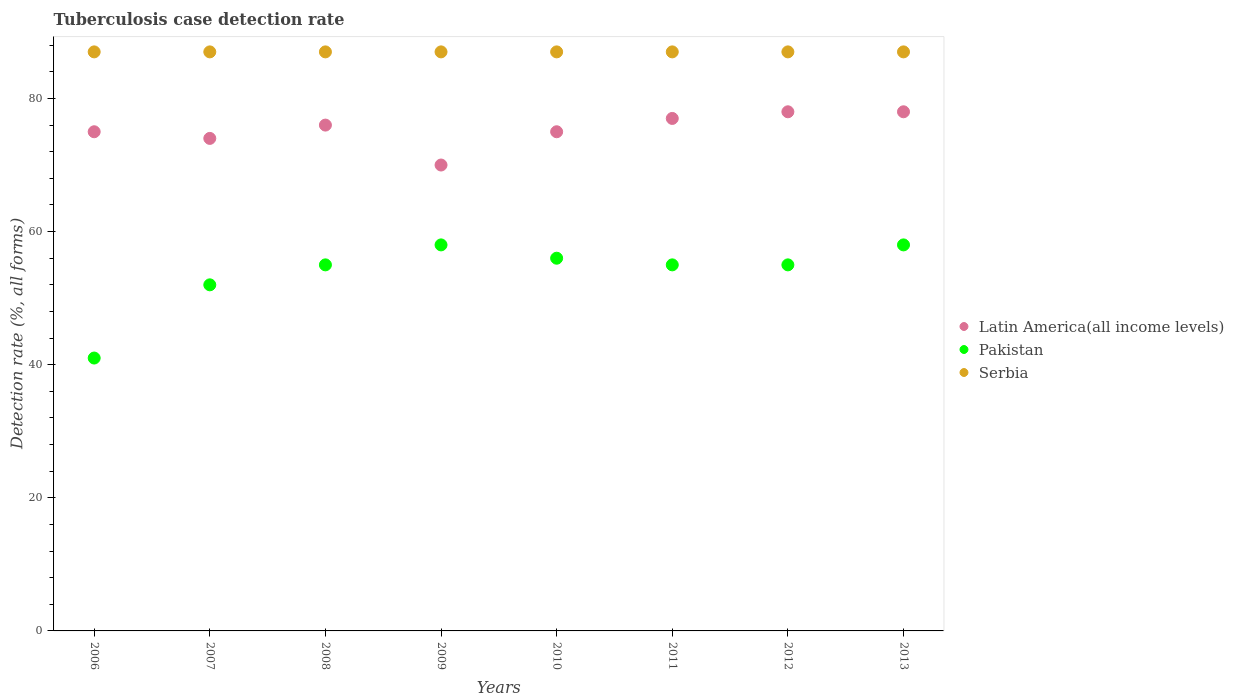Is the number of dotlines equal to the number of legend labels?
Provide a succinct answer. Yes. What is the tuberculosis case detection rate in in Latin America(all income levels) in 2011?
Provide a short and direct response. 77. Across all years, what is the maximum tuberculosis case detection rate in in Serbia?
Offer a terse response. 87. Across all years, what is the minimum tuberculosis case detection rate in in Latin America(all income levels)?
Your answer should be compact. 70. In which year was the tuberculosis case detection rate in in Latin America(all income levels) maximum?
Offer a terse response. 2012. In which year was the tuberculosis case detection rate in in Pakistan minimum?
Provide a succinct answer. 2006. What is the total tuberculosis case detection rate in in Latin America(all income levels) in the graph?
Your response must be concise. 603. What is the difference between the tuberculosis case detection rate in in Pakistan in 2009 and that in 2011?
Keep it short and to the point. 3. What is the difference between the tuberculosis case detection rate in in Latin America(all income levels) in 2011 and the tuberculosis case detection rate in in Serbia in 2007?
Your response must be concise. -10. What is the average tuberculosis case detection rate in in Serbia per year?
Make the answer very short. 87. In how many years, is the tuberculosis case detection rate in in Serbia greater than 80 %?
Your response must be concise. 8. What is the ratio of the tuberculosis case detection rate in in Latin America(all income levels) in 2008 to that in 2010?
Your answer should be compact. 1.01. Is the tuberculosis case detection rate in in Latin America(all income levels) in 2007 less than that in 2012?
Provide a succinct answer. Yes. Is the difference between the tuberculosis case detection rate in in Pakistan in 2011 and 2013 greater than the difference between the tuberculosis case detection rate in in Latin America(all income levels) in 2011 and 2013?
Ensure brevity in your answer.  No. What is the difference between the highest and the lowest tuberculosis case detection rate in in Serbia?
Offer a very short reply. 0. In how many years, is the tuberculosis case detection rate in in Serbia greater than the average tuberculosis case detection rate in in Serbia taken over all years?
Your answer should be very brief. 0. Is the sum of the tuberculosis case detection rate in in Serbia in 2006 and 2012 greater than the maximum tuberculosis case detection rate in in Pakistan across all years?
Your answer should be very brief. Yes. Is it the case that in every year, the sum of the tuberculosis case detection rate in in Pakistan and tuberculosis case detection rate in in Serbia  is greater than the tuberculosis case detection rate in in Latin America(all income levels)?
Your answer should be very brief. Yes. Is the tuberculosis case detection rate in in Pakistan strictly less than the tuberculosis case detection rate in in Latin America(all income levels) over the years?
Your response must be concise. Yes. How many years are there in the graph?
Provide a succinct answer. 8. What is the difference between two consecutive major ticks on the Y-axis?
Provide a succinct answer. 20. Does the graph contain grids?
Make the answer very short. No. How many legend labels are there?
Provide a succinct answer. 3. How are the legend labels stacked?
Your answer should be compact. Vertical. What is the title of the graph?
Give a very brief answer. Tuberculosis case detection rate. What is the label or title of the Y-axis?
Offer a terse response. Detection rate (%, all forms). What is the Detection rate (%, all forms) in Latin America(all income levels) in 2006?
Your answer should be compact. 75. What is the Detection rate (%, all forms) in Pakistan in 2007?
Offer a very short reply. 52. What is the Detection rate (%, all forms) of Latin America(all income levels) in 2008?
Give a very brief answer. 76. What is the Detection rate (%, all forms) in Pakistan in 2008?
Make the answer very short. 55. What is the Detection rate (%, all forms) of Latin America(all income levels) in 2009?
Your answer should be compact. 70. What is the Detection rate (%, all forms) of Pakistan in 2009?
Offer a very short reply. 58. What is the Detection rate (%, all forms) of Pakistan in 2010?
Give a very brief answer. 56. What is the Detection rate (%, all forms) in Serbia in 2011?
Make the answer very short. 87. What is the Detection rate (%, all forms) of Serbia in 2012?
Provide a short and direct response. 87. What is the Detection rate (%, all forms) of Latin America(all income levels) in 2013?
Offer a very short reply. 78. Across all years, what is the maximum Detection rate (%, all forms) in Latin America(all income levels)?
Offer a terse response. 78. Across all years, what is the maximum Detection rate (%, all forms) of Pakistan?
Your response must be concise. 58. Across all years, what is the maximum Detection rate (%, all forms) in Serbia?
Your answer should be compact. 87. Across all years, what is the minimum Detection rate (%, all forms) of Serbia?
Offer a terse response. 87. What is the total Detection rate (%, all forms) of Latin America(all income levels) in the graph?
Ensure brevity in your answer.  603. What is the total Detection rate (%, all forms) of Pakistan in the graph?
Give a very brief answer. 430. What is the total Detection rate (%, all forms) of Serbia in the graph?
Provide a short and direct response. 696. What is the difference between the Detection rate (%, all forms) in Latin America(all income levels) in 2006 and that in 2007?
Your response must be concise. 1. What is the difference between the Detection rate (%, all forms) in Serbia in 2006 and that in 2007?
Offer a very short reply. 0. What is the difference between the Detection rate (%, all forms) in Serbia in 2006 and that in 2008?
Offer a very short reply. 0. What is the difference between the Detection rate (%, all forms) in Serbia in 2006 and that in 2009?
Keep it short and to the point. 0. What is the difference between the Detection rate (%, all forms) in Serbia in 2006 and that in 2010?
Your response must be concise. 0. What is the difference between the Detection rate (%, all forms) in Pakistan in 2006 and that in 2011?
Provide a succinct answer. -14. What is the difference between the Detection rate (%, all forms) in Serbia in 2006 and that in 2011?
Your answer should be very brief. 0. What is the difference between the Detection rate (%, all forms) in Latin America(all income levels) in 2006 and that in 2012?
Offer a very short reply. -3. What is the difference between the Detection rate (%, all forms) of Pakistan in 2006 and that in 2012?
Provide a succinct answer. -14. What is the difference between the Detection rate (%, all forms) of Latin America(all income levels) in 2006 and that in 2013?
Make the answer very short. -3. What is the difference between the Detection rate (%, all forms) of Pakistan in 2006 and that in 2013?
Make the answer very short. -17. What is the difference between the Detection rate (%, all forms) of Serbia in 2006 and that in 2013?
Ensure brevity in your answer.  0. What is the difference between the Detection rate (%, all forms) in Latin America(all income levels) in 2007 and that in 2008?
Give a very brief answer. -2. What is the difference between the Detection rate (%, all forms) of Pakistan in 2007 and that in 2008?
Give a very brief answer. -3. What is the difference between the Detection rate (%, all forms) in Serbia in 2007 and that in 2008?
Provide a short and direct response. 0. What is the difference between the Detection rate (%, all forms) of Latin America(all income levels) in 2007 and that in 2009?
Offer a terse response. 4. What is the difference between the Detection rate (%, all forms) in Pakistan in 2007 and that in 2010?
Your answer should be very brief. -4. What is the difference between the Detection rate (%, all forms) in Latin America(all income levels) in 2007 and that in 2011?
Provide a succinct answer. -3. What is the difference between the Detection rate (%, all forms) in Pakistan in 2007 and that in 2011?
Ensure brevity in your answer.  -3. What is the difference between the Detection rate (%, all forms) in Latin America(all income levels) in 2007 and that in 2013?
Provide a short and direct response. -4. What is the difference between the Detection rate (%, all forms) in Pakistan in 2007 and that in 2013?
Ensure brevity in your answer.  -6. What is the difference between the Detection rate (%, all forms) of Serbia in 2007 and that in 2013?
Provide a short and direct response. 0. What is the difference between the Detection rate (%, all forms) of Pakistan in 2008 and that in 2009?
Keep it short and to the point. -3. What is the difference between the Detection rate (%, all forms) of Serbia in 2008 and that in 2009?
Your response must be concise. 0. What is the difference between the Detection rate (%, all forms) in Latin America(all income levels) in 2008 and that in 2010?
Make the answer very short. 1. What is the difference between the Detection rate (%, all forms) of Serbia in 2008 and that in 2010?
Your answer should be compact. 0. What is the difference between the Detection rate (%, all forms) of Latin America(all income levels) in 2008 and that in 2012?
Ensure brevity in your answer.  -2. What is the difference between the Detection rate (%, all forms) in Pakistan in 2008 and that in 2012?
Your response must be concise. 0. What is the difference between the Detection rate (%, all forms) in Latin America(all income levels) in 2008 and that in 2013?
Give a very brief answer. -2. What is the difference between the Detection rate (%, all forms) in Serbia in 2008 and that in 2013?
Your response must be concise. 0. What is the difference between the Detection rate (%, all forms) of Latin America(all income levels) in 2009 and that in 2010?
Provide a short and direct response. -5. What is the difference between the Detection rate (%, all forms) in Pakistan in 2009 and that in 2010?
Give a very brief answer. 2. What is the difference between the Detection rate (%, all forms) in Serbia in 2009 and that in 2010?
Your answer should be compact. 0. What is the difference between the Detection rate (%, all forms) in Latin America(all income levels) in 2009 and that in 2011?
Ensure brevity in your answer.  -7. What is the difference between the Detection rate (%, all forms) of Pakistan in 2009 and that in 2011?
Your answer should be very brief. 3. What is the difference between the Detection rate (%, all forms) in Serbia in 2009 and that in 2011?
Offer a very short reply. 0. What is the difference between the Detection rate (%, all forms) of Latin America(all income levels) in 2009 and that in 2012?
Your answer should be compact. -8. What is the difference between the Detection rate (%, all forms) of Pakistan in 2009 and that in 2012?
Keep it short and to the point. 3. What is the difference between the Detection rate (%, all forms) of Pakistan in 2009 and that in 2013?
Give a very brief answer. 0. What is the difference between the Detection rate (%, all forms) of Serbia in 2010 and that in 2012?
Keep it short and to the point. 0. What is the difference between the Detection rate (%, all forms) of Pakistan in 2010 and that in 2013?
Keep it short and to the point. -2. What is the difference between the Detection rate (%, all forms) in Serbia in 2010 and that in 2013?
Offer a very short reply. 0. What is the difference between the Detection rate (%, all forms) of Serbia in 2011 and that in 2012?
Make the answer very short. 0. What is the difference between the Detection rate (%, all forms) of Pakistan in 2011 and that in 2013?
Make the answer very short. -3. What is the difference between the Detection rate (%, all forms) of Serbia in 2011 and that in 2013?
Offer a terse response. 0. What is the difference between the Detection rate (%, all forms) of Serbia in 2012 and that in 2013?
Provide a succinct answer. 0. What is the difference between the Detection rate (%, all forms) in Latin America(all income levels) in 2006 and the Detection rate (%, all forms) in Serbia in 2007?
Provide a succinct answer. -12. What is the difference between the Detection rate (%, all forms) of Pakistan in 2006 and the Detection rate (%, all forms) of Serbia in 2007?
Provide a succinct answer. -46. What is the difference between the Detection rate (%, all forms) of Latin America(all income levels) in 2006 and the Detection rate (%, all forms) of Serbia in 2008?
Keep it short and to the point. -12. What is the difference between the Detection rate (%, all forms) in Pakistan in 2006 and the Detection rate (%, all forms) in Serbia in 2008?
Give a very brief answer. -46. What is the difference between the Detection rate (%, all forms) in Latin America(all income levels) in 2006 and the Detection rate (%, all forms) in Pakistan in 2009?
Keep it short and to the point. 17. What is the difference between the Detection rate (%, all forms) in Pakistan in 2006 and the Detection rate (%, all forms) in Serbia in 2009?
Offer a very short reply. -46. What is the difference between the Detection rate (%, all forms) of Latin America(all income levels) in 2006 and the Detection rate (%, all forms) of Pakistan in 2010?
Give a very brief answer. 19. What is the difference between the Detection rate (%, all forms) in Latin America(all income levels) in 2006 and the Detection rate (%, all forms) in Serbia in 2010?
Your answer should be very brief. -12. What is the difference between the Detection rate (%, all forms) of Pakistan in 2006 and the Detection rate (%, all forms) of Serbia in 2010?
Offer a very short reply. -46. What is the difference between the Detection rate (%, all forms) of Latin America(all income levels) in 2006 and the Detection rate (%, all forms) of Serbia in 2011?
Your response must be concise. -12. What is the difference between the Detection rate (%, all forms) of Pakistan in 2006 and the Detection rate (%, all forms) of Serbia in 2011?
Your answer should be compact. -46. What is the difference between the Detection rate (%, all forms) in Latin America(all income levels) in 2006 and the Detection rate (%, all forms) in Pakistan in 2012?
Provide a short and direct response. 20. What is the difference between the Detection rate (%, all forms) in Pakistan in 2006 and the Detection rate (%, all forms) in Serbia in 2012?
Offer a terse response. -46. What is the difference between the Detection rate (%, all forms) of Latin America(all income levels) in 2006 and the Detection rate (%, all forms) of Serbia in 2013?
Your answer should be compact. -12. What is the difference between the Detection rate (%, all forms) in Pakistan in 2006 and the Detection rate (%, all forms) in Serbia in 2013?
Provide a short and direct response. -46. What is the difference between the Detection rate (%, all forms) in Latin America(all income levels) in 2007 and the Detection rate (%, all forms) in Pakistan in 2008?
Offer a very short reply. 19. What is the difference between the Detection rate (%, all forms) of Pakistan in 2007 and the Detection rate (%, all forms) of Serbia in 2008?
Provide a short and direct response. -35. What is the difference between the Detection rate (%, all forms) of Latin America(all income levels) in 2007 and the Detection rate (%, all forms) of Pakistan in 2009?
Give a very brief answer. 16. What is the difference between the Detection rate (%, all forms) of Latin America(all income levels) in 2007 and the Detection rate (%, all forms) of Serbia in 2009?
Ensure brevity in your answer.  -13. What is the difference between the Detection rate (%, all forms) of Pakistan in 2007 and the Detection rate (%, all forms) of Serbia in 2009?
Your answer should be very brief. -35. What is the difference between the Detection rate (%, all forms) of Latin America(all income levels) in 2007 and the Detection rate (%, all forms) of Serbia in 2010?
Offer a very short reply. -13. What is the difference between the Detection rate (%, all forms) of Pakistan in 2007 and the Detection rate (%, all forms) of Serbia in 2010?
Provide a short and direct response. -35. What is the difference between the Detection rate (%, all forms) in Pakistan in 2007 and the Detection rate (%, all forms) in Serbia in 2011?
Offer a terse response. -35. What is the difference between the Detection rate (%, all forms) in Latin America(all income levels) in 2007 and the Detection rate (%, all forms) in Pakistan in 2012?
Make the answer very short. 19. What is the difference between the Detection rate (%, all forms) of Pakistan in 2007 and the Detection rate (%, all forms) of Serbia in 2012?
Offer a very short reply. -35. What is the difference between the Detection rate (%, all forms) in Latin America(all income levels) in 2007 and the Detection rate (%, all forms) in Serbia in 2013?
Give a very brief answer. -13. What is the difference between the Detection rate (%, all forms) of Pakistan in 2007 and the Detection rate (%, all forms) of Serbia in 2013?
Give a very brief answer. -35. What is the difference between the Detection rate (%, all forms) of Pakistan in 2008 and the Detection rate (%, all forms) of Serbia in 2009?
Your response must be concise. -32. What is the difference between the Detection rate (%, all forms) of Pakistan in 2008 and the Detection rate (%, all forms) of Serbia in 2010?
Make the answer very short. -32. What is the difference between the Detection rate (%, all forms) of Latin America(all income levels) in 2008 and the Detection rate (%, all forms) of Pakistan in 2011?
Your response must be concise. 21. What is the difference between the Detection rate (%, all forms) in Latin America(all income levels) in 2008 and the Detection rate (%, all forms) in Serbia in 2011?
Keep it short and to the point. -11. What is the difference between the Detection rate (%, all forms) of Pakistan in 2008 and the Detection rate (%, all forms) of Serbia in 2011?
Your response must be concise. -32. What is the difference between the Detection rate (%, all forms) of Pakistan in 2008 and the Detection rate (%, all forms) of Serbia in 2012?
Your response must be concise. -32. What is the difference between the Detection rate (%, all forms) of Latin America(all income levels) in 2008 and the Detection rate (%, all forms) of Pakistan in 2013?
Provide a short and direct response. 18. What is the difference between the Detection rate (%, all forms) in Latin America(all income levels) in 2008 and the Detection rate (%, all forms) in Serbia in 2013?
Offer a terse response. -11. What is the difference between the Detection rate (%, all forms) in Pakistan in 2008 and the Detection rate (%, all forms) in Serbia in 2013?
Ensure brevity in your answer.  -32. What is the difference between the Detection rate (%, all forms) of Latin America(all income levels) in 2009 and the Detection rate (%, all forms) of Pakistan in 2010?
Give a very brief answer. 14. What is the difference between the Detection rate (%, all forms) in Latin America(all income levels) in 2009 and the Detection rate (%, all forms) in Serbia in 2010?
Keep it short and to the point. -17. What is the difference between the Detection rate (%, all forms) of Pakistan in 2009 and the Detection rate (%, all forms) of Serbia in 2010?
Offer a terse response. -29. What is the difference between the Detection rate (%, all forms) in Latin America(all income levels) in 2009 and the Detection rate (%, all forms) in Pakistan in 2011?
Your response must be concise. 15. What is the difference between the Detection rate (%, all forms) in Pakistan in 2009 and the Detection rate (%, all forms) in Serbia in 2011?
Offer a terse response. -29. What is the difference between the Detection rate (%, all forms) in Latin America(all income levels) in 2009 and the Detection rate (%, all forms) in Pakistan in 2012?
Offer a terse response. 15. What is the difference between the Detection rate (%, all forms) in Latin America(all income levels) in 2009 and the Detection rate (%, all forms) in Serbia in 2012?
Your response must be concise. -17. What is the difference between the Detection rate (%, all forms) in Pakistan in 2009 and the Detection rate (%, all forms) in Serbia in 2013?
Give a very brief answer. -29. What is the difference between the Detection rate (%, all forms) in Latin America(all income levels) in 2010 and the Detection rate (%, all forms) in Pakistan in 2011?
Offer a very short reply. 20. What is the difference between the Detection rate (%, all forms) of Latin America(all income levels) in 2010 and the Detection rate (%, all forms) of Serbia in 2011?
Offer a terse response. -12. What is the difference between the Detection rate (%, all forms) in Pakistan in 2010 and the Detection rate (%, all forms) in Serbia in 2011?
Offer a very short reply. -31. What is the difference between the Detection rate (%, all forms) of Latin America(all income levels) in 2010 and the Detection rate (%, all forms) of Serbia in 2012?
Provide a succinct answer. -12. What is the difference between the Detection rate (%, all forms) of Pakistan in 2010 and the Detection rate (%, all forms) of Serbia in 2012?
Offer a very short reply. -31. What is the difference between the Detection rate (%, all forms) in Latin America(all income levels) in 2010 and the Detection rate (%, all forms) in Pakistan in 2013?
Your response must be concise. 17. What is the difference between the Detection rate (%, all forms) of Pakistan in 2010 and the Detection rate (%, all forms) of Serbia in 2013?
Your response must be concise. -31. What is the difference between the Detection rate (%, all forms) in Latin America(all income levels) in 2011 and the Detection rate (%, all forms) in Pakistan in 2012?
Your answer should be very brief. 22. What is the difference between the Detection rate (%, all forms) in Pakistan in 2011 and the Detection rate (%, all forms) in Serbia in 2012?
Provide a short and direct response. -32. What is the difference between the Detection rate (%, all forms) of Latin America(all income levels) in 2011 and the Detection rate (%, all forms) of Pakistan in 2013?
Keep it short and to the point. 19. What is the difference between the Detection rate (%, all forms) in Pakistan in 2011 and the Detection rate (%, all forms) in Serbia in 2013?
Ensure brevity in your answer.  -32. What is the difference between the Detection rate (%, all forms) of Pakistan in 2012 and the Detection rate (%, all forms) of Serbia in 2013?
Your response must be concise. -32. What is the average Detection rate (%, all forms) in Latin America(all income levels) per year?
Your answer should be compact. 75.38. What is the average Detection rate (%, all forms) in Pakistan per year?
Offer a very short reply. 53.75. What is the average Detection rate (%, all forms) in Serbia per year?
Your answer should be compact. 87. In the year 2006, what is the difference between the Detection rate (%, all forms) in Latin America(all income levels) and Detection rate (%, all forms) in Serbia?
Offer a terse response. -12. In the year 2006, what is the difference between the Detection rate (%, all forms) in Pakistan and Detection rate (%, all forms) in Serbia?
Provide a short and direct response. -46. In the year 2007, what is the difference between the Detection rate (%, all forms) in Latin America(all income levels) and Detection rate (%, all forms) in Pakistan?
Make the answer very short. 22. In the year 2007, what is the difference between the Detection rate (%, all forms) of Latin America(all income levels) and Detection rate (%, all forms) of Serbia?
Offer a very short reply. -13. In the year 2007, what is the difference between the Detection rate (%, all forms) in Pakistan and Detection rate (%, all forms) in Serbia?
Provide a short and direct response. -35. In the year 2008, what is the difference between the Detection rate (%, all forms) in Latin America(all income levels) and Detection rate (%, all forms) in Pakistan?
Give a very brief answer. 21. In the year 2008, what is the difference between the Detection rate (%, all forms) of Pakistan and Detection rate (%, all forms) of Serbia?
Offer a very short reply. -32. In the year 2009, what is the difference between the Detection rate (%, all forms) of Latin America(all income levels) and Detection rate (%, all forms) of Serbia?
Keep it short and to the point. -17. In the year 2010, what is the difference between the Detection rate (%, all forms) in Latin America(all income levels) and Detection rate (%, all forms) in Pakistan?
Provide a short and direct response. 19. In the year 2010, what is the difference between the Detection rate (%, all forms) in Latin America(all income levels) and Detection rate (%, all forms) in Serbia?
Make the answer very short. -12. In the year 2010, what is the difference between the Detection rate (%, all forms) of Pakistan and Detection rate (%, all forms) of Serbia?
Offer a very short reply. -31. In the year 2011, what is the difference between the Detection rate (%, all forms) in Pakistan and Detection rate (%, all forms) in Serbia?
Offer a terse response. -32. In the year 2012, what is the difference between the Detection rate (%, all forms) of Latin America(all income levels) and Detection rate (%, all forms) of Pakistan?
Provide a short and direct response. 23. In the year 2012, what is the difference between the Detection rate (%, all forms) of Pakistan and Detection rate (%, all forms) of Serbia?
Offer a very short reply. -32. In the year 2013, what is the difference between the Detection rate (%, all forms) in Pakistan and Detection rate (%, all forms) in Serbia?
Give a very brief answer. -29. What is the ratio of the Detection rate (%, all forms) in Latin America(all income levels) in 2006 to that in 2007?
Your answer should be very brief. 1.01. What is the ratio of the Detection rate (%, all forms) in Pakistan in 2006 to that in 2007?
Your response must be concise. 0.79. What is the ratio of the Detection rate (%, all forms) of Serbia in 2006 to that in 2007?
Offer a terse response. 1. What is the ratio of the Detection rate (%, all forms) of Pakistan in 2006 to that in 2008?
Keep it short and to the point. 0.75. What is the ratio of the Detection rate (%, all forms) in Latin America(all income levels) in 2006 to that in 2009?
Provide a succinct answer. 1.07. What is the ratio of the Detection rate (%, all forms) of Pakistan in 2006 to that in 2009?
Ensure brevity in your answer.  0.71. What is the ratio of the Detection rate (%, all forms) in Serbia in 2006 to that in 2009?
Your response must be concise. 1. What is the ratio of the Detection rate (%, all forms) of Pakistan in 2006 to that in 2010?
Give a very brief answer. 0.73. What is the ratio of the Detection rate (%, all forms) in Latin America(all income levels) in 2006 to that in 2011?
Offer a very short reply. 0.97. What is the ratio of the Detection rate (%, all forms) in Pakistan in 2006 to that in 2011?
Your answer should be compact. 0.75. What is the ratio of the Detection rate (%, all forms) of Serbia in 2006 to that in 2011?
Offer a terse response. 1. What is the ratio of the Detection rate (%, all forms) of Latin America(all income levels) in 2006 to that in 2012?
Offer a terse response. 0.96. What is the ratio of the Detection rate (%, all forms) in Pakistan in 2006 to that in 2012?
Keep it short and to the point. 0.75. What is the ratio of the Detection rate (%, all forms) of Latin America(all income levels) in 2006 to that in 2013?
Offer a terse response. 0.96. What is the ratio of the Detection rate (%, all forms) in Pakistan in 2006 to that in 2013?
Make the answer very short. 0.71. What is the ratio of the Detection rate (%, all forms) in Latin America(all income levels) in 2007 to that in 2008?
Provide a short and direct response. 0.97. What is the ratio of the Detection rate (%, all forms) of Pakistan in 2007 to that in 2008?
Make the answer very short. 0.95. What is the ratio of the Detection rate (%, all forms) of Latin America(all income levels) in 2007 to that in 2009?
Your response must be concise. 1.06. What is the ratio of the Detection rate (%, all forms) of Pakistan in 2007 to that in 2009?
Your answer should be compact. 0.9. What is the ratio of the Detection rate (%, all forms) in Serbia in 2007 to that in 2009?
Offer a terse response. 1. What is the ratio of the Detection rate (%, all forms) in Latin America(all income levels) in 2007 to that in 2010?
Ensure brevity in your answer.  0.99. What is the ratio of the Detection rate (%, all forms) in Serbia in 2007 to that in 2010?
Ensure brevity in your answer.  1. What is the ratio of the Detection rate (%, all forms) in Latin America(all income levels) in 2007 to that in 2011?
Keep it short and to the point. 0.96. What is the ratio of the Detection rate (%, all forms) of Pakistan in 2007 to that in 2011?
Ensure brevity in your answer.  0.95. What is the ratio of the Detection rate (%, all forms) in Latin America(all income levels) in 2007 to that in 2012?
Your answer should be very brief. 0.95. What is the ratio of the Detection rate (%, all forms) in Pakistan in 2007 to that in 2012?
Ensure brevity in your answer.  0.95. What is the ratio of the Detection rate (%, all forms) of Serbia in 2007 to that in 2012?
Provide a short and direct response. 1. What is the ratio of the Detection rate (%, all forms) in Latin America(all income levels) in 2007 to that in 2013?
Provide a short and direct response. 0.95. What is the ratio of the Detection rate (%, all forms) of Pakistan in 2007 to that in 2013?
Provide a succinct answer. 0.9. What is the ratio of the Detection rate (%, all forms) in Serbia in 2007 to that in 2013?
Keep it short and to the point. 1. What is the ratio of the Detection rate (%, all forms) in Latin America(all income levels) in 2008 to that in 2009?
Your answer should be compact. 1.09. What is the ratio of the Detection rate (%, all forms) of Pakistan in 2008 to that in 2009?
Offer a terse response. 0.95. What is the ratio of the Detection rate (%, all forms) in Latin America(all income levels) in 2008 to that in 2010?
Provide a succinct answer. 1.01. What is the ratio of the Detection rate (%, all forms) in Pakistan in 2008 to that in 2010?
Ensure brevity in your answer.  0.98. What is the ratio of the Detection rate (%, all forms) of Pakistan in 2008 to that in 2011?
Provide a succinct answer. 1. What is the ratio of the Detection rate (%, all forms) in Latin America(all income levels) in 2008 to that in 2012?
Keep it short and to the point. 0.97. What is the ratio of the Detection rate (%, all forms) of Serbia in 2008 to that in 2012?
Offer a terse response. 1. What is the ratio of the Detection rate (%, all forms) of Latin America(all income levels) in 2008 to that in 2013?
Keep it short and to the point. 0.97. What is the ratio of the Detection rate (%, all forms) in Pakistan in 2008 to that in 2013?
Offer a very short reply. 0.95. What is the ratio of the Detection rate (%, all forms) in Latin America(all income levels) in 2009 to that in 2010?
Give a very brief answer. 0.93. What is the ratio of the Detection rate (%, all forms) in Pakistan in 2009 to that in 2010?
Provide a succinct answer. 1.04. What is the ratio of the Detection rate (%, all forms) of Serbia in 2009 to that in 2010?
Your answer should be compact. 1. What is the ratio of the Detection rate (%, all forms) in Latin America(all income levels) in 2009 to that in 2011?
Make the answer very short. 0.91. What is the ratio of the Detection rate (%, all forms) of Pakistan in 2009 to that in 2011?
Provide a short and direct response. 1.05. What is the ratio of the Detection rate (%, all forms) in Latin America(all income levels) in 2009 to that in 2012?
Offer a terse response. 0.9. What is the ratio of the Detection rate (%, all forms) of Pakistan in 2009 to that in 2012?
Your answer should be very brief. 1.05. What is the ratio of the Detection rate (%, all forms) of Serbia in 2009 to that in 2012?
Provide a succinct answer. 1. What is the ratio of the Detection rate (%, all forms) in Latin America(all income levels) in 2009 to that in 2013?
Provide a succinct answer. 0.9. What is the ratio of the Detection rate (%, all forms) of Pakistan in 2009 to that in 2013?
Provide a succinct answer. 1. What is the ratio of the Detection rate (%, all forms) of Serbia in 2009 to that in 2013?
Keep it short and to the point. 1. What is the ratio of the Detection rate (%, all forms) of Latin America(all income levels) in 2010 to that in 2011?
Ensure brevity in your answer.  0.97. What is the ratio of the Detection rate (%, all forms) in Pakistan in 2010 to that in 2011?
Keep it short and to the point. 1.02. What is the ratio of the Detection rate (%, all forms) of Serbia in 2010 to that in 2011?
Offer a very short reply. 1. What is the ratio of the Detection rate (%, all forms) of Latin America(all income levels) in 2010 to that in 2012?
Give a very brief answer. 0.96. What is the ratio of the Detection rate (%, all forms) of Pakistan in 2010 to that in 2012?
Offer a very short reply. 1.02. What is the ratio of the Detection rate (%, all forms) of Serbia in 2010 to that in 2012?
Ensure brevity in your answer.  1. What is the ratio of the Detection rate (%, all forms) in Latin America(all income levels) in 2010 to that in 2013?
Make the answer very short. 0.96. What is the ratio of the Detection rate (%, all forms) in Pakistan in 2010 to that in 2013?
Make the answer very short. 0.97. What is the ratio of the Detection rate (%, all forms) of Serbia in 2010 to that in 2013?
Make the answer very short. 1. What is the ratio of the Detection rate (%, all forms) of Latin America(all income levels) in 2011 to that in 2012?
Keep it short and to the point. 0.99. What is the ratio of the Detection rate (%, all forms) of Pakistan in 2011 to that in 2012?
Give a very brief answer. 1. What is the ratio of the Detection rate (%, all forms) of Serbia in 2011 to that in 2012?
Your answer should be very brief. 1. What is the ratio of the Detection rate (%, all forms) in Latin America(all income levels) in 2011 to that in 2013?
Offer a very short reply. 0.99. What is the ratio of the Detection rate (%, all forms) in Pakistan in 2011 to that in 2013?
Provide a short and direct response. 0.95. What is the ratio of the Detection rate (%, all forms) in Latin America(all income levels) in 2012 to that in 2013?
Your answer should be compact. 1. What is the ratio of the Detection rate (%, all forms) of Pakistan in 2012 to that in 2013?
Offer a very short reply. 0.95. What is the ratio of the Detection rate (%, all forms) of Serbia in 2012 to that in 2013?
Your response must be concise. 1. What is the difference between the highest and the second highest Detection rate (%, all forms) of Serbia?
Provide a short and direct response. 0. What is the difference between the highest and the lowest Detection rate (%, all forms) of Latin America(all income levels)?
Ensure brevity in your answer.  8. 